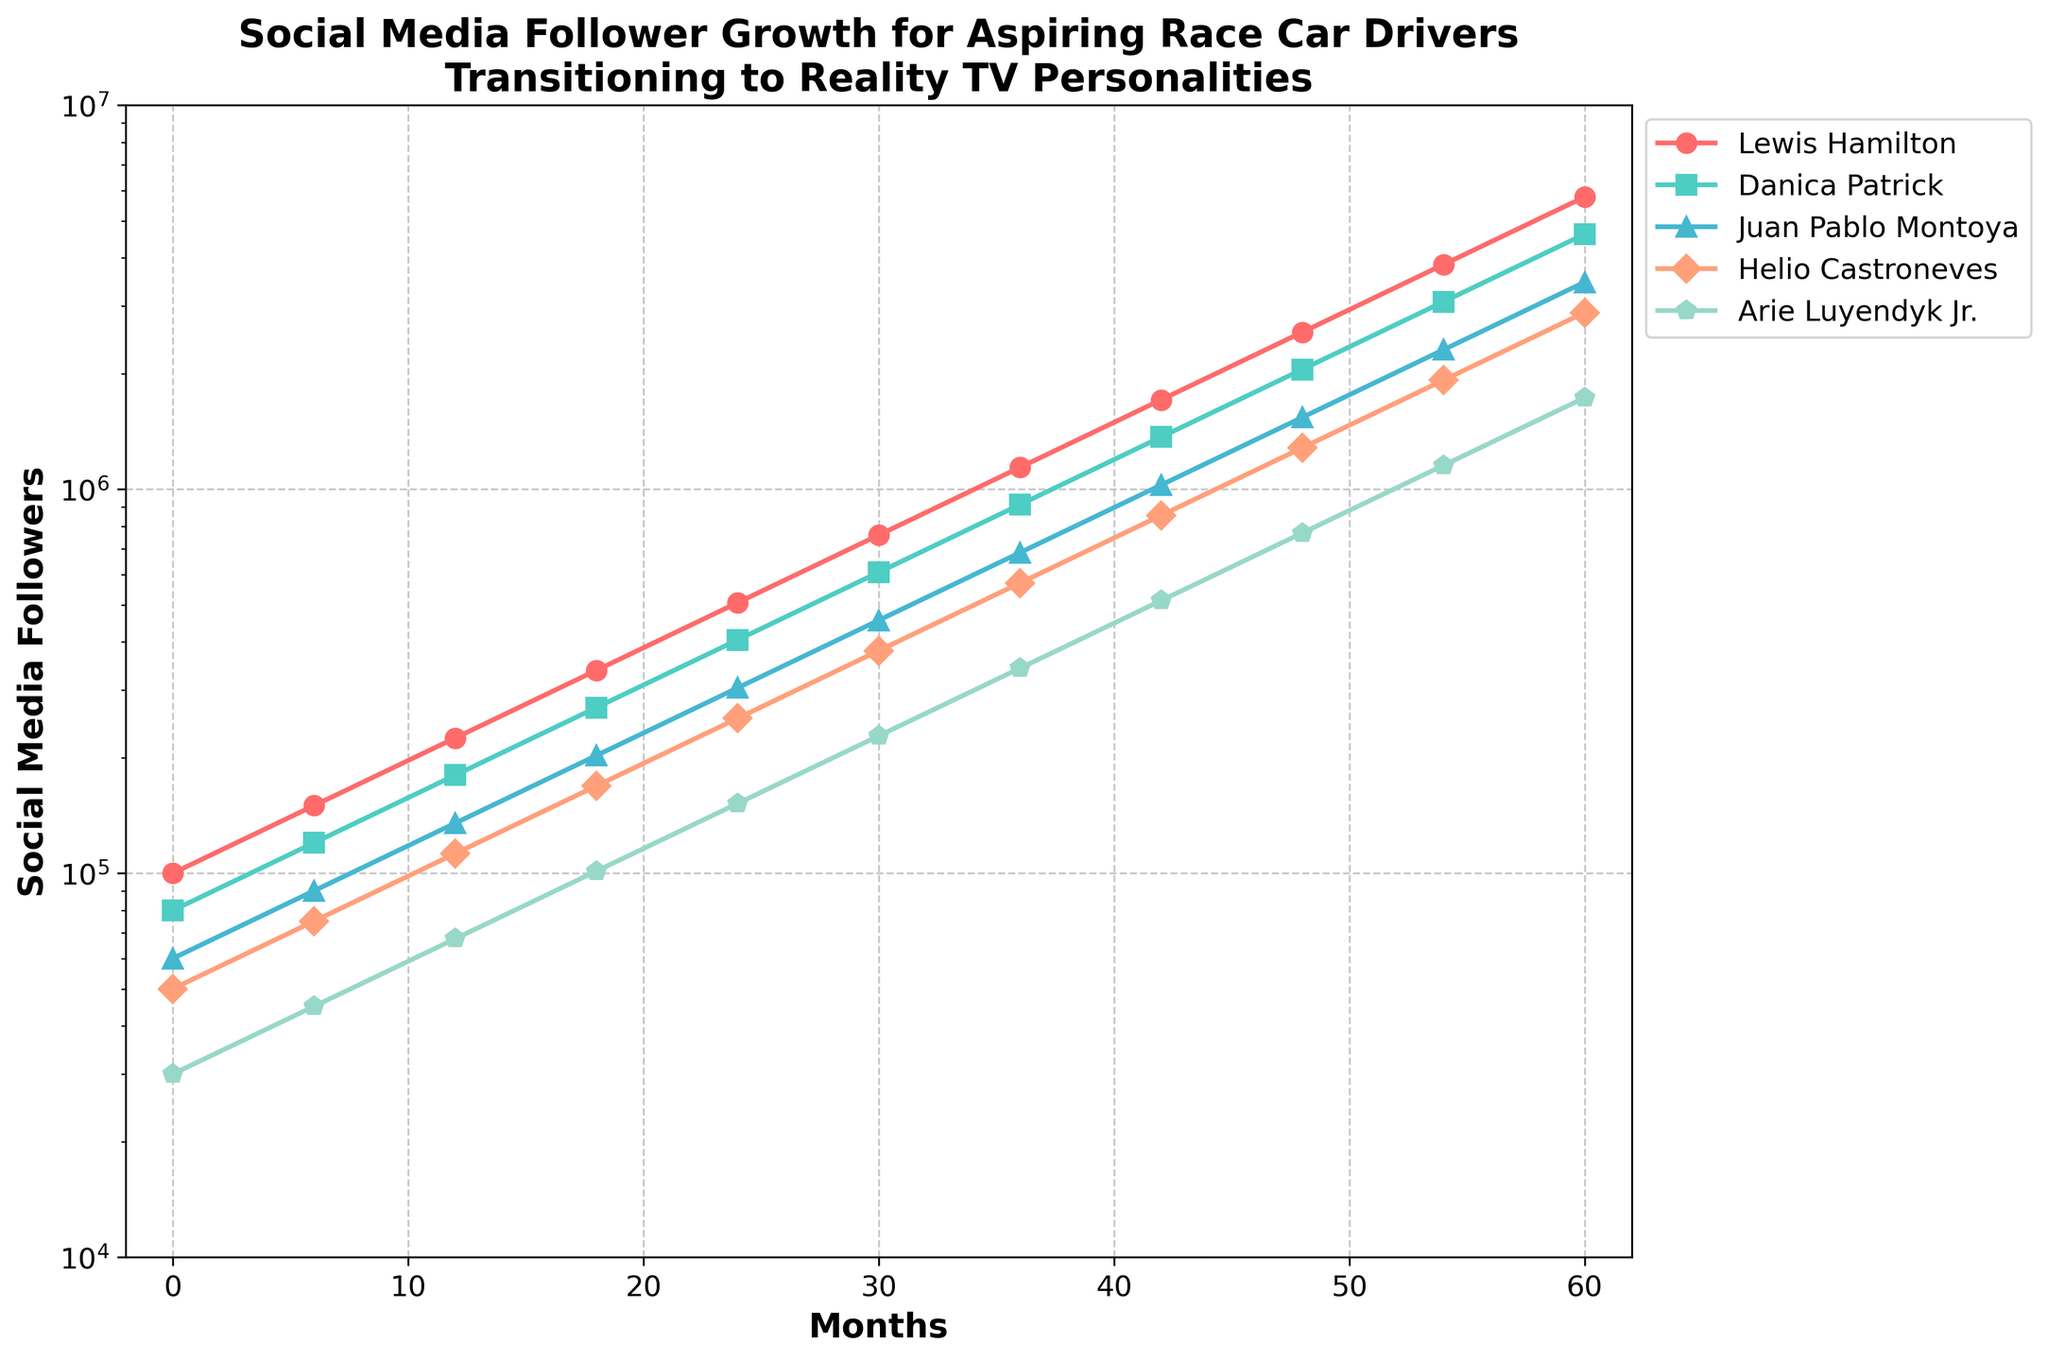What is the total number of followers for Lewis Hamilton at the end of 5 years? Look at the data point for Lewis Hamilton at the last month (Month 60). The number of followers is 5,766,504.
Answer: 5,766,504 Which race car driver had the highest follower count at the end of 5 years? Compare the data points for each driver at Month 60. Lewis Hamilton has the highest follower count with 5,766,504 followers.
Answer: Lewis Hamilton How many more followers does Helio Castroneves have than Arie Luyendyk Jr. at Month 48? Subtract the follower count of Arie Luyendyk Jr. from Helio Castroneves at Month 48 (1,281,445 - 768,867).
Answer: 512,578 What is the average number of followers for Danica Patrick at Months 0, 24, and 48? Sum up the follower counts for Danica Patrick at Months 0, 24, and 48 (80,000 + 405,000 + 2,050,313) and divide by 3.
Answer: 845,104.33 Between which two consecutive months did Juan Pablo Montoya experience the largest increase in followers? Calculate the difference in follower count between each consecutive month and identify the largest difference. The largest increase is between Month 48 and Month 54 (3,075,469 - 2,307,734 = 767,735).
Answer: Months 48 and 54 Which driver's followers grew the fastest in the first year? Compare the increase in follower count from Month 0 to Month 12 for each driver. Lewis Hamilton's followers increased the most from 100,000 to 225,000.
Answer: Lewis Hamilton By how much did the follower count for Arie Luyendyk Jr. increase from Month 0 to Month 60? Subtract the follower count at Month 0 from Month 60 for Arie Luyendyk Jr. (1,729,951 - 30,000).
Answer: 1,699,951 Which driver had the smallest follower count at Month 18? Look at the data points for Month 18. Arie Luyendyk Jr. had the smallest follower count with 101,250 followers.
Answer: Arie Luyendyk Jr Which driver's follower growth appears to be almost exponential on the plot? Visually inspect the plot and note that Lewis Hamilton's follower growth shows an exponential pattern, growing significantly steeper over time.
Answer: Lewis Hamilton Compare the follower count of Danica Patrick at Month 60 to that of Juan Pablo Montoya at Month 48. Which is higher and by how much? Compare the counts for each: Danica Patrick at Month 60 is 4,613,203 and Juan Pablo Montoya at Month 48 is 1,537,734. Subtract to find the difference (4,613,203 - 1,537,734).
Answer: Danica Patrick by 3,075,469 